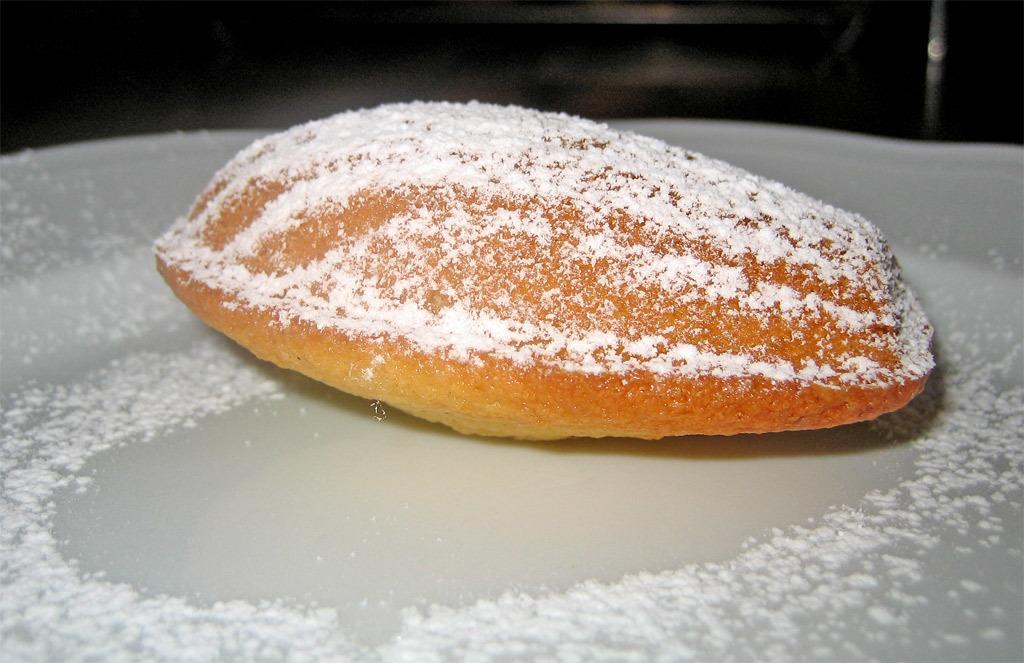Could you give a brief overview of what you see in this image? In this image I can see a food on the white surface. Food is in brown and white color. 